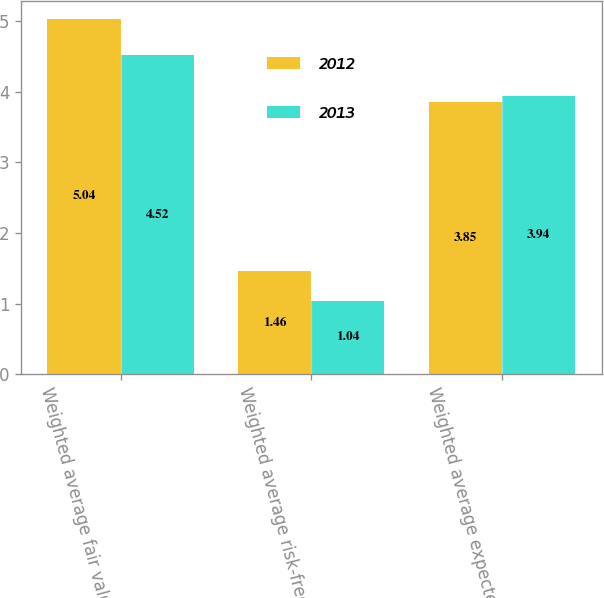<chart> <loc_0><loc_0><loc_500><loc_500><stacked_bar_chart><ecel><fcel>Weighted average fair value of<fcel>Weighted average risk-free<fcel>Weighted average expected<nl><fcel>2012<fcel>5.04<fcel>1.46<fcel>3.85<nl><fcel>2013<fcel>4.52<fcel>1.04<fcel>3.94<nl></chart> 